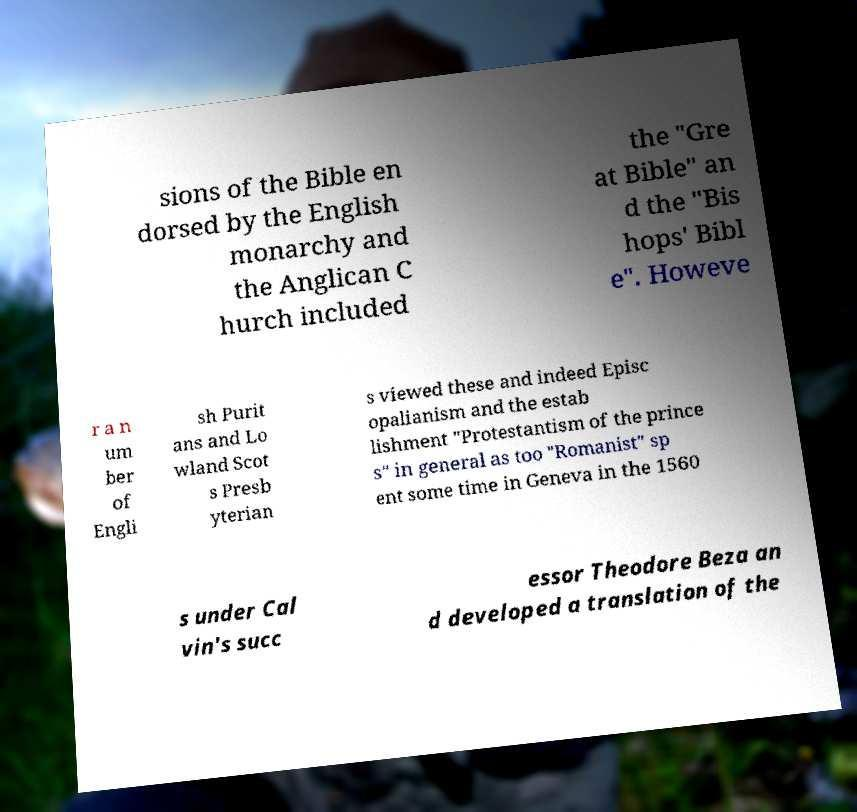What messages or text are displayed in this image? I need them in a readable, typed format. sions of the Bible en dorsed by the English monarchy and the Anglican C hurch included the "Gre at Bible" an d the "Bis hops' Bibl e". Howeve r a n um ber of Engli sh Purit ans and Lo wland Scot s Presb yterian s viewed these and indeed Episc opalianism and the estab lishment "Protestantism of the prince s" in general as too "Romanist" sp ent some time in Geneva in the 1560 s under Cal vin's succ essor Theodore Beza an d developed a translation of the 